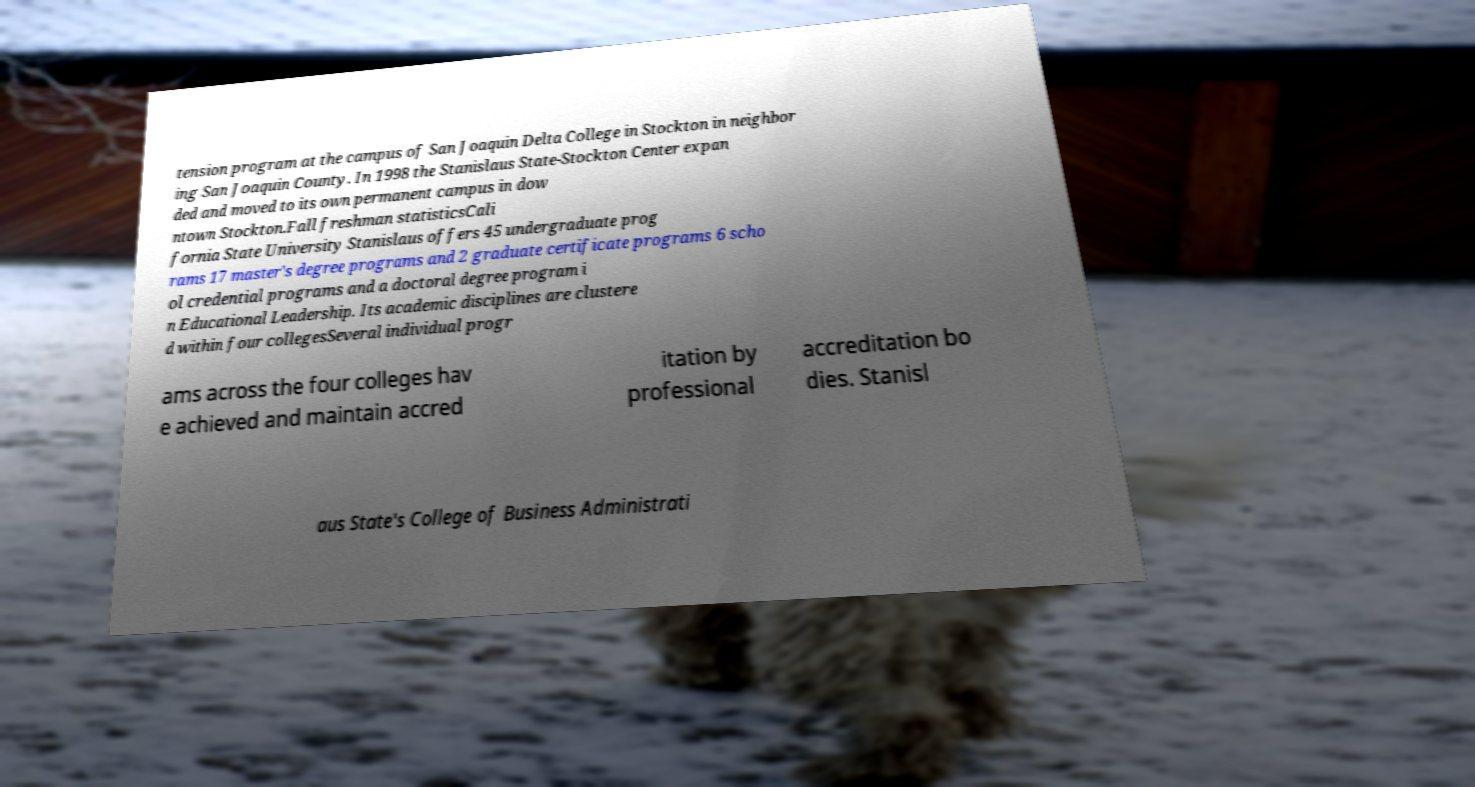I need the written content from this picture converted into text. Can you do that? tension program at the campus of San Joaquin Delta College in Stockton in neighbor ing San Joaquin County. In 1998 the Stanislaus State-Stockton Center expan ded and moved to its own permanent campus in dow ntown Stockton.Fall freshman statisticsCali fornia State University Stanislaus offers 45 undergraduate prog rams 17 master's degree programs and 2 graduate certificate programs 6 scho ol credential programs and a doctoral degree program i n Educational Leadership. Its academic disciplines are clustere d within four collegesSeveral individual progr ams across the four colleges hav e achieved and maintain accred itation by professional accreditation bo dies. Stanisl aus State's College of Business Administrati 